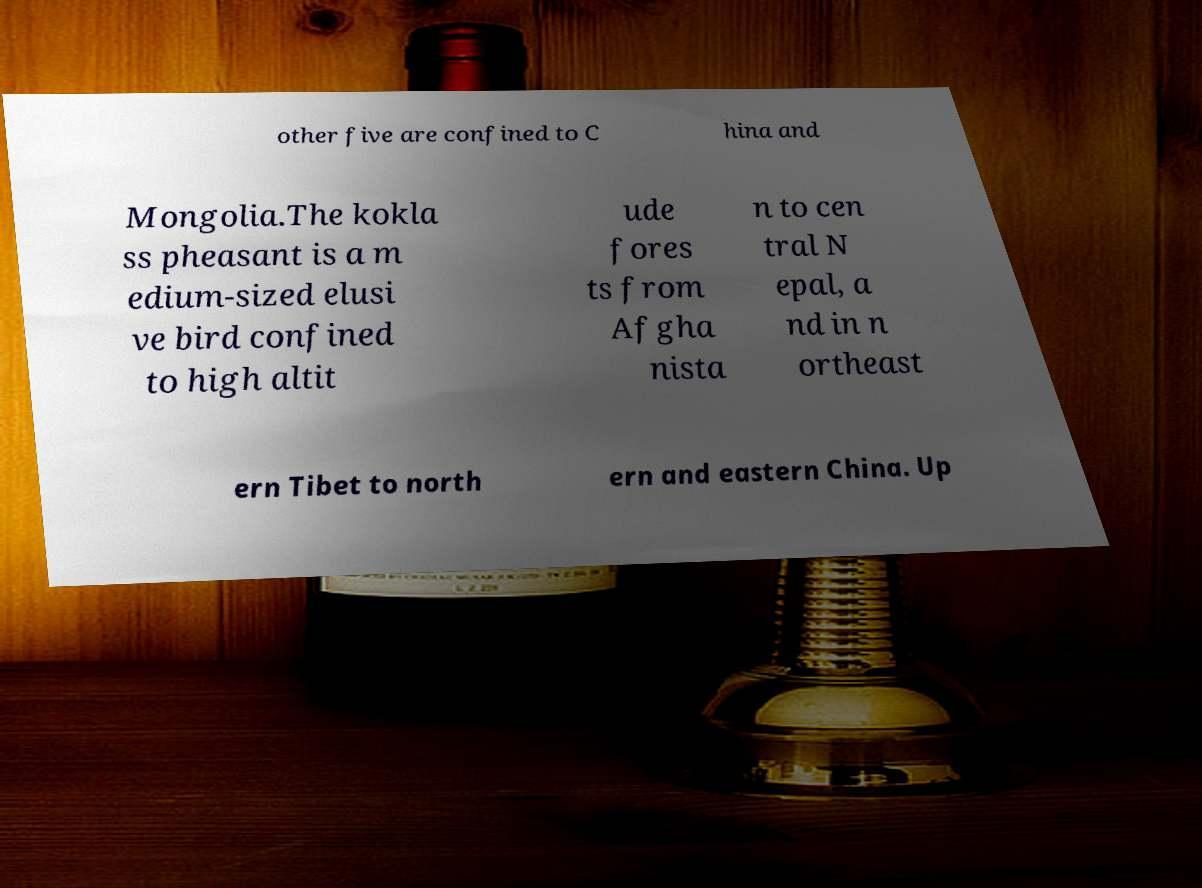Please read and relay the text visible in this image. What does it say? other five are confined to C hina and Mongolia.The kokla ss pheasant is a m edium-sized elusi ve bird confined to high altit ude fores ts from Afgha nista n to cen tral N epal, a nd in n ortheast ern Tibet to north ern and eastern China. Up 